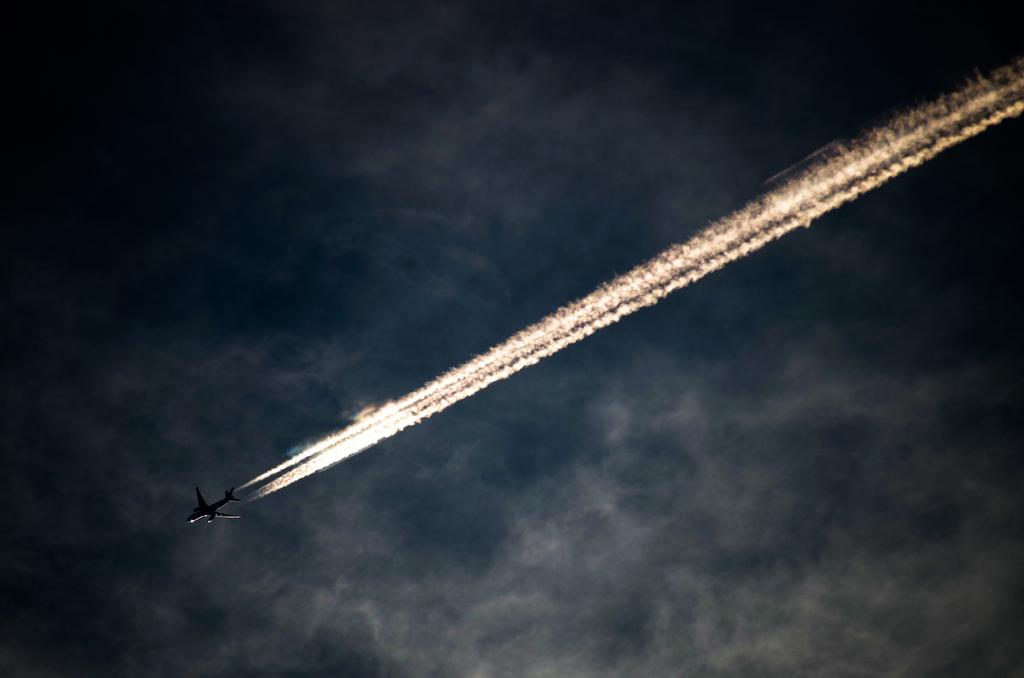What is the main subject of the image? There is a flight flying in the image. What can be seen coming from the flight? There is smoke visible in the image. What is visible in the background of the image? There is sky with clouds in the background of the image. How many giants can be seen holding the brush in the image? There are no giants or brushes present in the image. 